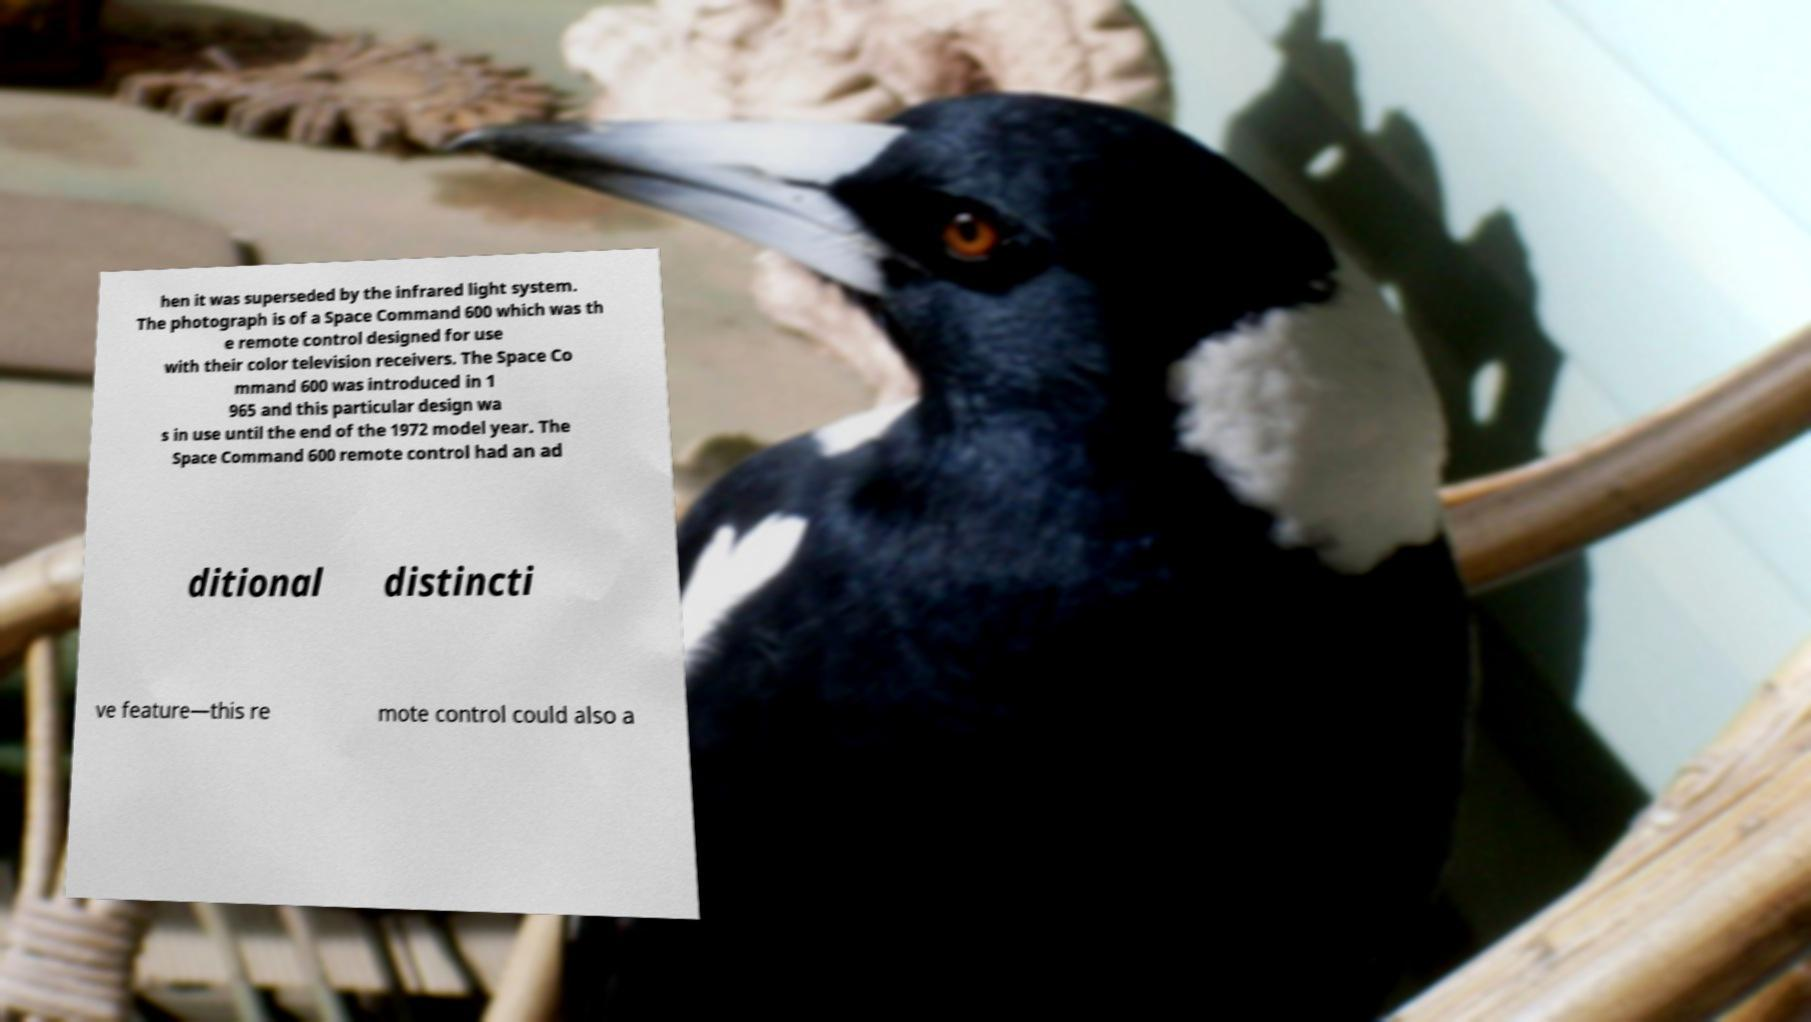Please read and relay the text visible in this image. What does it say? hen it was superseded by the infrared light system. The photograph is of a Space Command 600 which was th e remote control designed for use with their color television receivers. The Space Co mmand 600 was introduced in 1 965 and this particular design wa s in use until the end of the 1972 model year. The Space Command 600 remote control had an ad ditional distincti ve feature—this re mote control could also a 